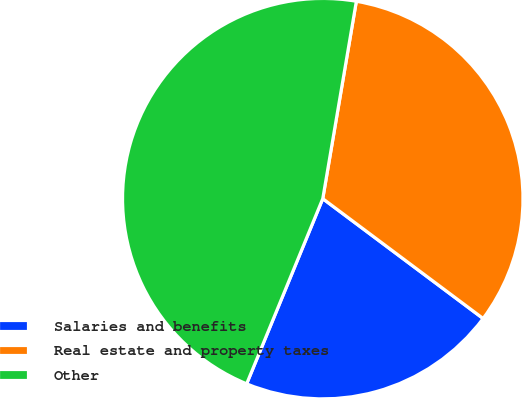<chart> <loc_0><loc_0><loc_500><loc_500><pie_chart><fcel>Salaries and benefits<fcel>Real estate and property taxes<fcel>Other<nl><fcel>20.99%<fcel>32.53%<fcel>46.47%<nl></chart> 